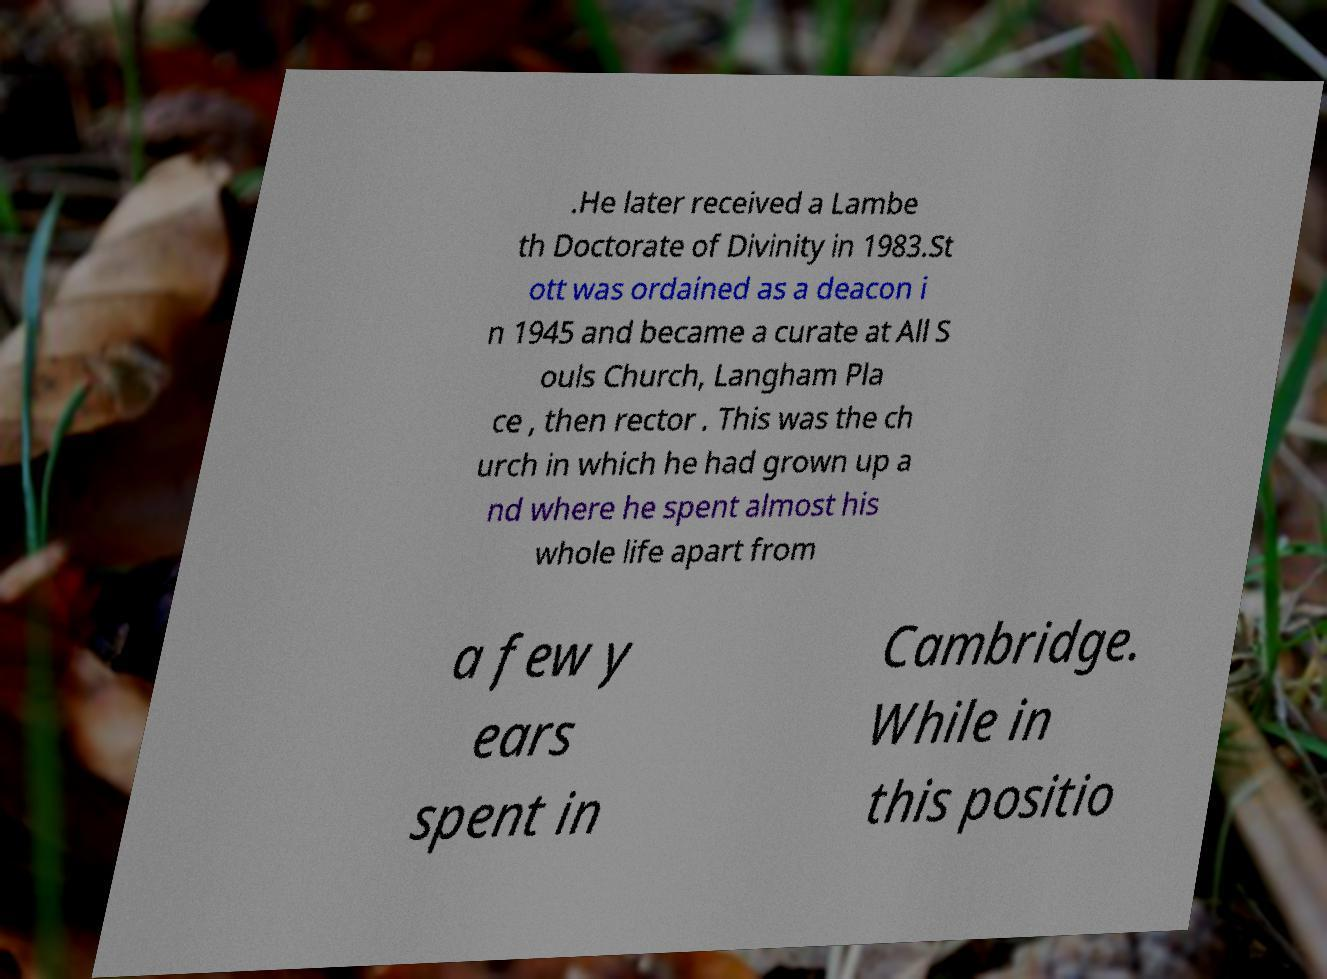Please identify and transcribe the text found in this image. .He later received a Lambe th Doctorate of Divinity in 1983.St ott was ordained as a deacon i n 1945 and became a curate at All S ouls Church, Langham Pla ce , then rector . This was the ch urch in which he had grown up a nd where he spent almost his whole life apart from a few y ears spent in Cambridge. While in this positio 